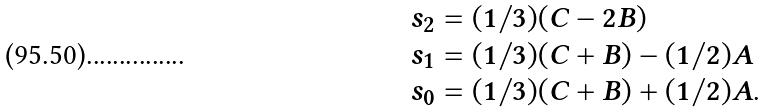<formula> <loc_0><loc_0><loc_500><loc_500>\begin{array} { l } { { s _ { 2 } = ( 1 / 3 ) ( C - 2 B ) } } \\ { { s _ { 1 } = ( 1 / 3 ) ( C + B ) - ( 1 / 2 ) A } } \\ { { s _ { 0 } = ( 1 / 3 ) ( C + B ) + ( 1 / 2 ) A . } } \end{array}</formula> 